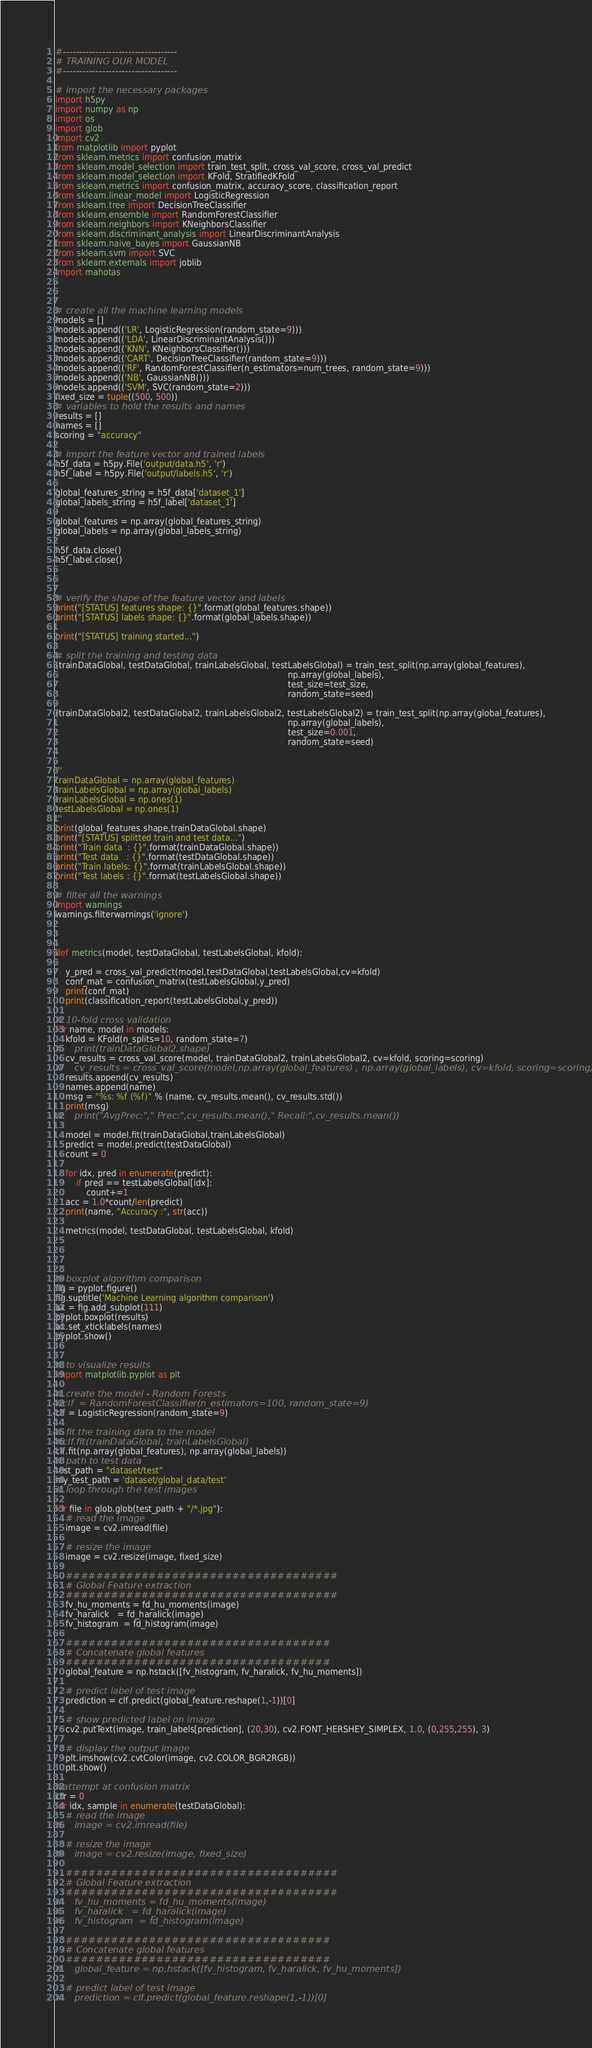<code> <loc_0><loc_0><loc_500><loc_500><_Python_>#-----------------------------------
# TRAINING OUR MODEL
#-----------------------------------

# import the necessary packages
import h5py
import numpy as np
import os
import glob
import cv2
from matplotlib import pyplot
from sklearn.metrics import confusion_matrix
from sklearn.model_selection import train_test_split, cross_val_score, cross_val_predict
from sklearn.model_selection import KFold, StratifiedKFold
from sklearn.metrics import confusion_matrix, accuracy_score, classification_report
from sklearn.linear_model import LogisticRegression
from sklearn.tree import DecisionTreeClassifier
from sklearn.ensemble import RandomForestClassifier
from sklearn.neighbors import KNeighborsClassifier
from sklearn.discriminant_analysis import LinearDiscriminantAnalysis
from sklearn.naive_bayes import GaussianNB
from sklearn.svm import SVC
from sklearn.externals import joblib
import mahotas



# create all the machine learning models
models = []
models.append(('LR', LogisticRegression(random_state=9)))
models.append(('LDA', LinearDiscriminantAnalysis()))
models.append(('KNN', KNeighborsClassifier()))
models.append(('CART', DecisionTreeClassifier(random_state=9)))
models.append(('RF', RandomForestClassifier(n_estimators=num_trees, random_state=9)))
models.append(('NB', GaussianNB()))
models.append(('SVM', SVC(random_state=2)))
fixed_size = tuple((500, 500))
# variables to hold the results and names
results = []
names = []
scoring = "accuracy"

# import the feature vector and trained labels
h5f_data = h5py.File('output/data.h5', 'r')
h5f_label = h5py.File('output/labels.h5', 'r')

global_features_string = h5f_data['dataset_1']
global_labels_string = h5f_label['dataset_1']

global_features = np.array(global_features_string)
global_labels = np.array(global_labels_string)

h5f_data.close()
h5f_label.close()



# verify the shape of the feature vector and labels
print("[STATUS] features shape: {}".format(global_features.shape))
print("[STATUS] labels shape: {}".format(global_labels.shape))

print("[STATUS] training started...")

# split the training and testing data
(trainDataGlobal, testDataGlobal, trainLabelsGlobal, testLabelsGlobal) = train_test_split(np.array(global_features),
                                                                                          np.array(global_labels),
                                                                                          test_size=test_size,
                                                                                          random_state=seed)

(trainDataGlobal2, testDataGlobal2, trainLabelsGlobal2, testLabelsGlobal2) = train_test_split(np.array(global_features),
                                                                                          np.array(global_labels),
                                                                                          test_size=0.001,
                                                                                          random_state=seed)


'''
trainDataGlobal = np.array(global_features)
trainLabelsGlobal = np.array(global_labels)
trainLabelsGlobal = np.ones(1)
testLabelsGlobal = np.ones(1)
'''
print(global_features.shape,trainDataGlobal.shape)
print("[STATUS] splitted train and test data...")
print("Train data  : {}".format(trainDataGlobal.shape))
print("Test data   : {}".format(testDataGlobal.shape))
print("Train labels: {}".format(trainLabelsGlobal.shape))
print("Test labels : {}".format(testLabelsGlobal.shape))

# filter all the warnings
import warnings
warnings.filterwarnings('ignore')



def metrics(model, testDataGlobal, testLabelsGlobal, kfold):
    
    y_pred = cross_val_predict(model,testDataGlobal,testLabelsGlobal,cv=kfold)
    conf_mat = confusion_matrix(testLabelsGlobal,y_pred)
    print(conf_mat)
    print(classification_report(testLabelsGlobal,y_pred))

# 10-fold cross validation
for name, model in models:
    kfold = KFold(n_splits=10, random_state=7)
#    print(trainDataGlobal2.shape)
    cv_results = cross_val_score(model, trainDataGlobal2, trainLabelsGlobal2, cv=kfold, scoring=scoring)
#    cv_results = cross_val_score(model,np.array(global_features) , np.array(global_labels), cv=kfold, scoring=scoring)
    results.append(cv_results)
    names.append(name)
    msg = "%s: %f (%f)" % (name, cv_results.mean(), cv_results.std())
    print(msg)
#    print("AvgPrec:"," Prec:",cv_results.mean()," Recall:",cv_results.mean())
    
    model = model.fit(trainDataGlobal,trainLabelsGlobal)
    predict = model.predict(testDataGlobal)
    count = 0
    
    for idx, pred in enumerate(predict):
        if pred == testLabelsGlobal[idx]:
            count+=1
    acc = 1.0*count/len(predict)
    print(name, "Accuracy :", str(acc))
    
    metrics(model, testDataGlobal, testLabelsGlobal, kfold)
    
   
    

# boxplot algorithm comparison
fig = pyplot.figure()
fig.suptitle('Machine Learning algorithm comparison')
ax = fig.add_subplot(111)
pyplot.boxplot(results)
ax.set_xticklabels(names)
pyplot.show()


# to visualize results
import matplotlib.pyplot as plt

# create the model - Random Forests
#clf  = RandomForestClassifier(n_estimators=100, random_state=9)
clf = LogisticRegression(random_state=9)

# fit the training data to the model
#clf.fit(trainDataGlobal, trainLabelsGlobal)
clf.fit(np.array(global_features), np.array(global_labels))
# path to test data
test_path = "dataset/test"
my_test_path = 'dataset/global_data/test'
# loop through the test images

for file in glob.glob(test_path + "/*.jpg"):
    # read the image
    image = cv2.imread(file)

    # resize the image
    image = cv2.resize(image, fixed_size)

    ####################################
    # Global Feature extraction
    ####################################
    fv_hu_moments = fd_hu_moments(image)
    fv_haralick   = fd_haralick(image)
    fv_histogram  = fd_histogram(image)

    ###################################
    # Concatenate global features
    ###################################
    global_feature = np.hstack([fv_histogram, fv_haralick, fv_hu_moments])

    # predict label of test image
    prediction = clf.predict(global_feature.reshape(1,-1))[0]

    # show predicted label on image
    cv2.putText(image, train_labels[prediction], (20,30), cv2.FONT_HERSHEY_SIMPLEX, 1.0, (0,255,255), 3)

    # display the output image
    plt.imshow(cv2.cvtColor(image, cv2.COLOR_BGR2RGB))
    plt.show()

#attempt at confusion matrix
ctr = 0
for idx, sample in enumerate(testDataGlobal):
    # read the image
#    image = cv2.imread(file)

    # resize the image
#    image = cv2.resize(image, fixed_size)

    ####################################
    # Global Feature extraction
    ####################################
#    fv_hu_moments = fd_hu_moments(image)
#    fv_haralick   = fd_haralick(image)
#    fv_histogram  = fd_histogram(image)

    ###################################
    # Concatenate global features
    ###################################
#    global_feature = np.hstack([fv_histogram, fv_haralick, fv_hu_moments])

    # predict label of test image
#    prediction = clf.predict(global_feature.reshape(1,-1))[0]
</code> 